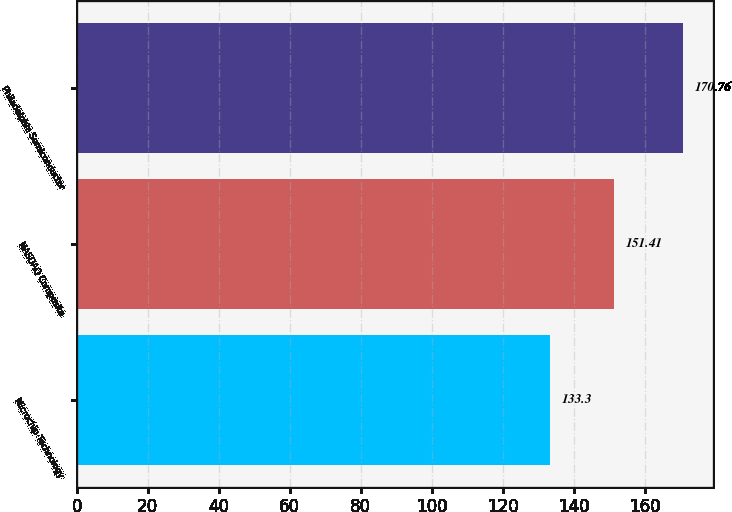Convert chart. <chart><loc_0><loc_0><loc_500><loc_500><bar_chart><fcel>Microchip Technology<fcel>NASDAQ Composite<fcel>Philadelphia Semiconductor<nl><fcel>133.3<fcel>151.41<fcel>170.76<nl></chart> 